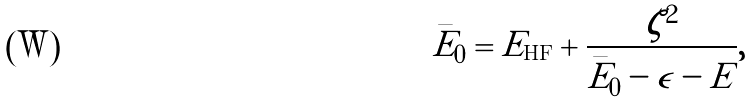Convert formula to latex. <formula><loc_0><loc_0><loc_500><loc_500>\bar { E } _ { 0 } = E _ { \text {HF} } + \frac { \zeta ^ { 2 } } { \bar { E } _ { 0 } - \epsilon - E } ,</formula> 